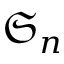<formula> <loc_0><loc_0><loc_500><loc_500>{ \mathfrak { S } } _ { n }</formula> 